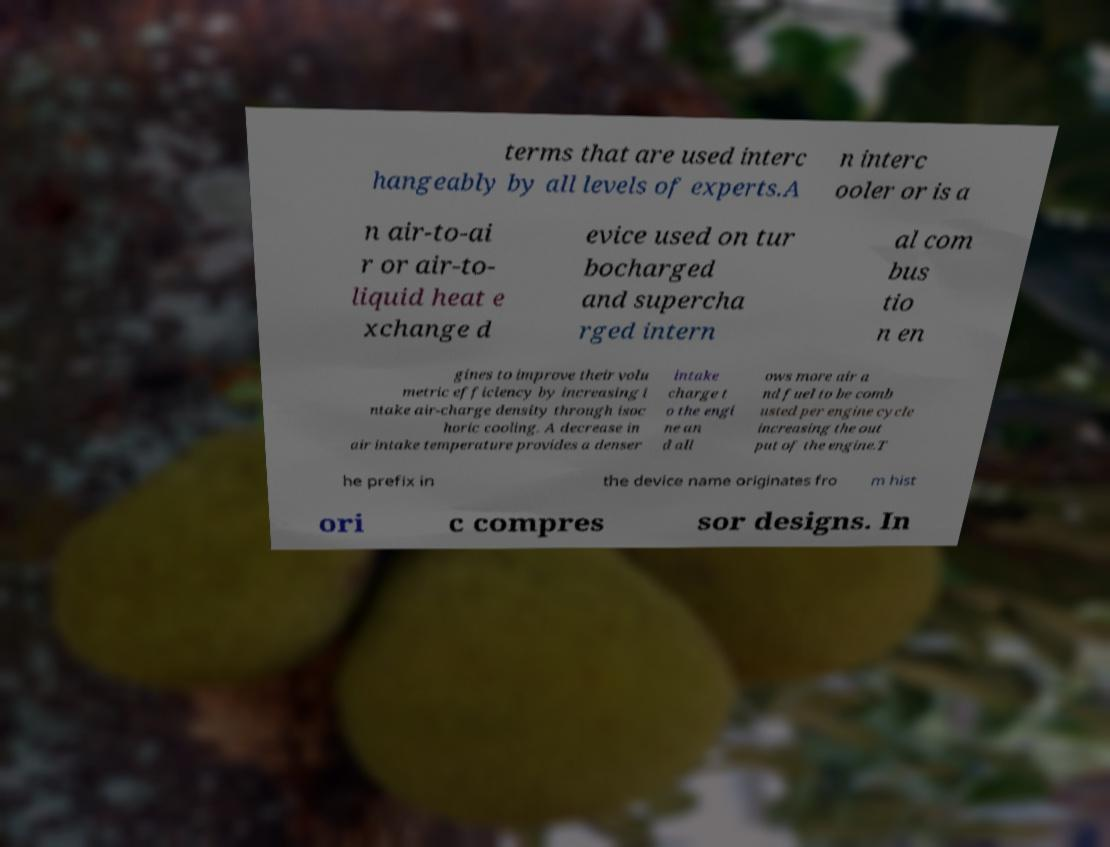Please identify and transcribe the text found in this image. terms that are used interc hangeably by all levels of experts.A n interc ooler or is a n air-to-ai r or air-to- liquid heat e xchange d evice used on tur bocharged and supercha rged intern al com bus tio n en gines to improve their volu metric efficiency by increasing i ntake air-charge density through isoc horic cooling. A decrease in air intake temperature provides a denser intake charge t o the engi ne an d all ows more air a nd fuel to be comb usted per engine cycle increasing the out put of the engine.T he prefix in the device name originates fro m hist ori c compres sor designs. In 